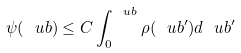<formula> <loc_0><loc_0><loc_500><loc_500>\psi ( \ u b ) \leq C \int _ { 0 } ^ { \ u b } \rho ( \ u b ^ { \prime } ) d \ u b ^ { \prime }</formula> 